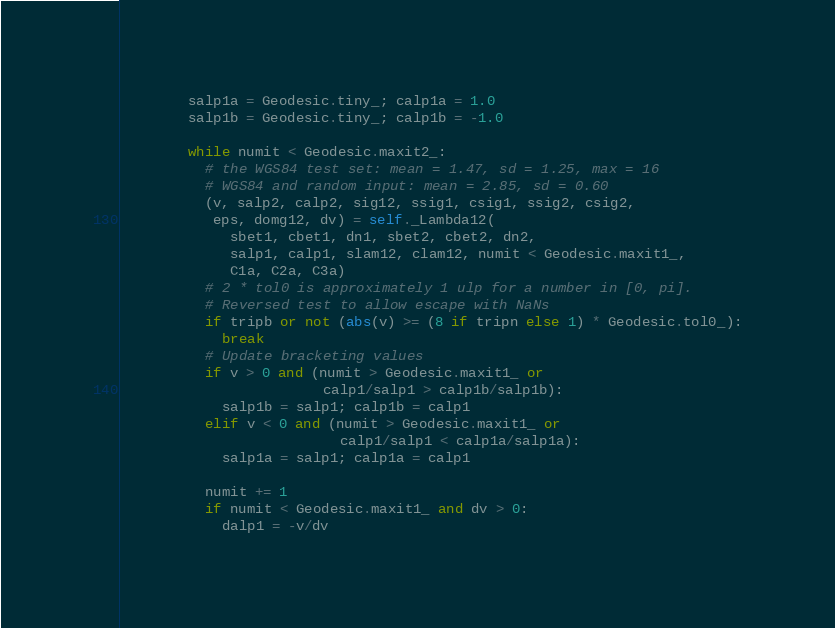Convert code to text. <code><loc_0><loc_0><loc_500><loc_500><_Python_>        salp1a = Geodesic.tiny_; calp1a = 1.0
        salp1b = Geodesic.tiny_; calp1b = -1.0

        while numit < Geodesic.maxit2_:
          # the WGS84 test set: mean = 1.47, sd = 1.25, max = 16
          # WGS84 and random input: mean = 2.85, sd = 0.60
          (v, salp2, calp2, sig12, ssig1, csig1, ssig2, csig2,
           eps, domg12, dv) = self._Lambda12(
             sbet1, cbet1, dn1, sbet2, cbet2, dn2,
             salp1, calp1, slam12, clam12, numit < Geodesic.maxit1_,
             C1a, C2a, C3a)
          # 2 * tol0 is approximately 1 ulp for a number in [0, pi].
          # Reversed test to allow escape with NaNs
          if tripb or not (abs(v) >= (8 if tripn else 1) * Geodesic.tol0_):
            break
          # Update bracketing values
          if v > 0 and (numit > Geodesic.maxit1_ or
                        calp1/salp1 > calp1b/salp1b):
            salp1b = salp1; calp1b = calp1
          elif v < 0 and (numit > Geodesic.maxit1_ or
                          calp1/salp1 < calp1a/salp1a):
            salp1a = salp1; calp1a = calp1

          numit += 1
          if numit < Geodesic.maxit1_ and dv > 0:
            dalp1 = -v/dv</code> 